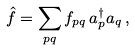Convert formula to latex. <formula><loc_0><loc_0><loc_500><loc_500>\hat { f } = \sum _ { p q } f _ { p q } \, a _ { p } ^ { \dag } a _ { q } \, ,</formula> 